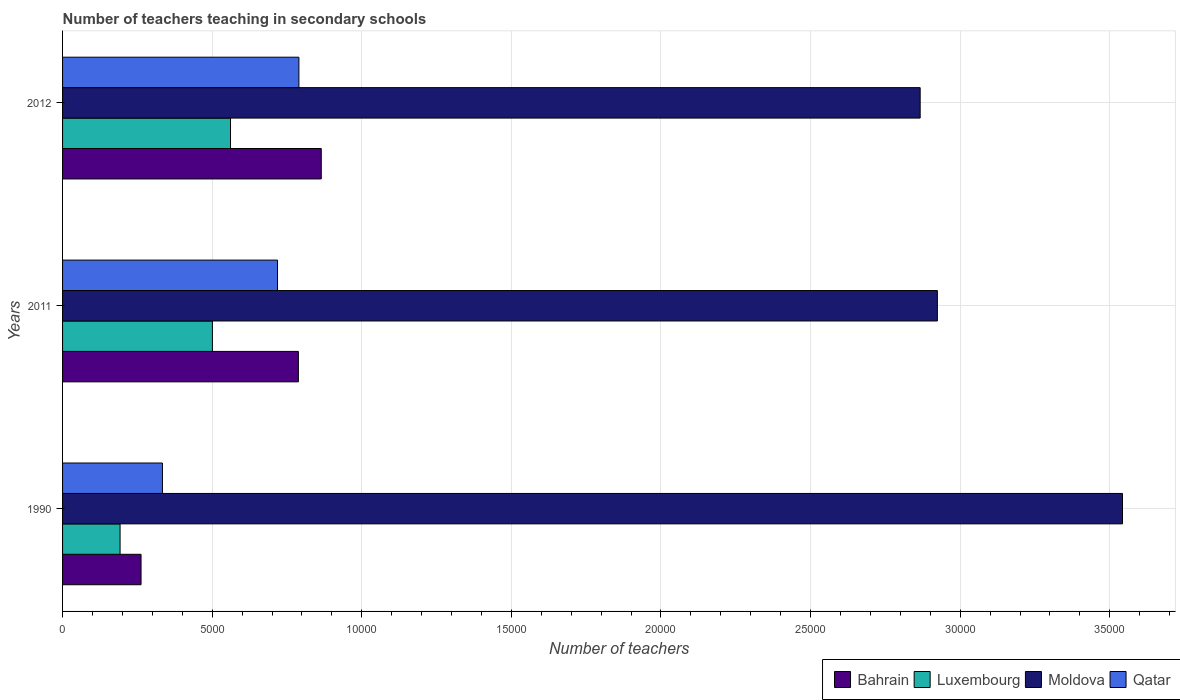What is the label of the 1st group of bars from the top?
Provide a succinct answer. 2012. What is the number of teachers teaching in secondary schools in Moldova in 1990?
Your response must be concise. 3.54e+04. Across all years, what is the maximum number of teachers teaching in secondary schools in Moldova?
Your answer should be very brief. 3.54e+04. Across all years, what is the minimum number of teachers teaching in secondary schools in Luxembourg?
Keep it short and to the point. 1922. In which year was the number of teachers teaching in secondary schools in Moldova maximum?
Give a very brief answer. 1990. In which year was the number of teachers teaching in secondary schools in Luxembourg minimum?
Make the answer very short. 1990. What is the total number of teachers teaching in secondary schools in Moldova in the graph?
Offer a terse response. 9.33e+04. What is the difference between the number of teachers teaching in secondary schools in Bahrain in 2011 and that in 2012?
Offer a terse response. -765. What is the difference between the number of teachers teaching in secondary schools in Bahrain in 1990 and the number of teachers teaching in secondary schools in Moldova in 2011?
Offer a very short reply. -2.66e+04. What is the average number of teachers teaching in secondary schools in Bahrain per year?
Provide a succinct answer. 6383.33. In the year 2012, what is the difference between the number of teachers teaching in secondary schools in Luxembourg and number of teachers teaching in secondary schools in Bahrain?
Give a very brief answer. -3033. What is the ratio of the number of teachers teaching in secondary schools in Bahrain in 1990 to that in 2012?
Offer a terse response. 0.3. Is the number of teachers teaching in secondary schools in Moldova in 1990 less than that in 2011?
Ensure brevity in your answer.  No. Is the difference between the number of teachers teaching in secondary schools in Luxembourg in 2011 and 2012 greater than the difference between the number of teachers teaching in secondary schools in Bahrain in 2011 and 2012?
Ensure brevity in your answer.  Yes. What is the difference between the highest and the second highest number of teachers teaching in secondary schools in Moldova?
Your answer should be compact. 6187. What is the difference between the highest and the lowest number of teachers teaching in secondary schools in Bahrain?
Give a very brief answer. 6023. In how many years, is the number of teachers teaching in secondary schools in Luxembourg greater than the average number of teachers teaching in secondary schools in Luxembourg taken over all years?
Keep it short and to the point. 2. Is the sum of the number of teachers teaching in secondary schools in Qatar in 1990 and 2012 greater than the maximum number of teachers teaching in secondary schools in Bahrain across all years?
Your response must be concise. Yes. Is it the case that in every year, the sum of the number of teachers teaching in secondary schools in Qatar and number of teachers teaching in secondary schools in Bahrain is greater than the sum of number of teachers teaching in secondary schools in Luxembourg and number of teachers teaching in secondary schools in Moldova?
Your answer should be compact. No. What does the 2nd bar from the top in 2011 represents?
Provide a succinct answer. Moldova. What does the 1st bar from the bottom in 2012 represents?
Your response must be concise. Bahrain. Is it the case that in every year, the sum of the number of teachers teaching in secondary schools in Moldova and number of teachers teaching in secondary schools in Luxembourg is greater than the number of teachers teaching in secondary schools in Bahrain?
Ensure brevity in your answer.  Yes. How many bars are there?
Your answer should be very brief. 12. How many years are there in the graph?
Offer a very short reply. 3. What is the difference between two consecutive major ticks on the X-axis?
Ensure brevity in your answer.  5000. Are the values on the major ticks of X-axis written in scientific E-notation?
Provide a short and direct response. No. Does the graph contain any zero values?
Make the answer very short. No. Does the graph contain grids?
Keep it short and to the point. Yes. Where does the legend appear in the graph?
Your response must be concise. Bottom right. How many legend labels are there?
Your answer should be very brief. 4. What is the title of the graph?
Your answer should be compact. Number of teachers teaching in secondary schools. What is the label or title of the X-axis?
Your answer should be compact. Number of teachers. What is the label or title of the Y-axis?
Make the answer very short. Years. What is the Number of teachers in Bahrain in 1990?
Offer a terse response. 2623. What is the Number of teachers in Luxembourg in 1990?
Provide a short and direct response. 1922. What is the Number of teachers in Moldova in 1990?
Give a very brief answer. 3.54e+04. What is the Number of teachers of Qatar in 1990?
Make the answer very short. 3338. What is the Number of teachers in Bahrain in 2011?
Offer a terse response. 7881. What is the Number of teachers of Luxembourg in 2011?
Give a very brief answer. 5008. What is the Number of teachers in Moldova in 2011?
Offer a terse response. 2.92e+04. What is the Number of teachers of Qatar in 2011?
Make the answer very short. 7184. What is the Number of teachers in Bahrain in 2012?
Keep it short and to the point. 8646. What is the Number of teachers of Luxembourg in 2012?
Provide a succinct answer. 5613. What is the Number of teachers in Moldova in 2012?
Keep it short and to the point. 2.87e+04. What is the Number of teachers in Qatar in 2012?
Keep it short and to the point. 7899. Across all years, what is the maximum Number of teachers in Bahrain?
Offer a very short reply. 8646. Across all years, what is the maximum Number of teachers of Luxembourg?
Offer a terse response. 5613. Across all years, what is the maximum Number of teachers in Moldova?
Offer a very short reply. 3.54e+04. Across all years, what is the maximum Number of teachers in Qatar?
Give a very brief answer. 7899. Across all years, what is the minimum Number of teachers in Bahrain?
Keep it short and to the point. 2623. Across all years, what is the minimum Number of teachers in Luxembourg?
Ensure brevity in your answer.  1922. Across all years, what is the minimum Number of teachers in Moldova?
Provide a succinct answer. 2.87e+04. Across all years, what is the minimum Number of teachers of Qatar?
Keep it short and to the point. 3338. What is the total Number of teachers in Bahrain in the graph?
Offer a very short reply. 1.92e+04. What is the total Number of teachers in Luxembourg in the graph?
Your response must be concise. 1.25e+04. What is the total Number of teachers of Moldova in the graph?
Make the answer very short. 9.33e+04. What is the total Number of teachers of Qatar in the graph?
Your response must be concise. 1.84e+04. What is the difference between the Number of teachers of Bahrain in 1990 and that in 2011?
Ensure brevity in your answer.  -5258. What is the difference between the Number of teachers in Luxembourg in 1990 and that in 2011?
Your response must be concise. -3086. What is the difference between the Number of teachers of Moldova in 1990 and that in 2011?
Provide a succinct answer. 6187. What is the difference between the Number of teachers in Qatar in 1990 and that in 2011?
Your answer should be very brief. -3846. What is the difference between the Number of teachers in Bahrain in 1990 and that in 2012?
Give a very brief answer. -6023. What is the difference between the Number of teachers of Luxembourg in 1990 and that in 2012?
Provide a short and direct response. -3691. What is the difference between the Number of teachers in Moldova in 1990 and that in 2012?
Your response must be concise. 6762. What is the difference between the Number of teachers in Qatar in 1990 and that in 2012?
Make the answer very short. -4561. What is the difference between the Number of teachers of Bahrain in 2011 and that in 2012?
Give a very brief answer. -765. What is the difference between the Number of teachers in Luxembourg in 2011 and that in 2012?
Your response must be concise. -605. What is the difference between the Number of teachers of Moldova in 2011 and that in 2012?
Provide a succinct answer. 575. What is the difference between the Number of teachers in Qatar in 2011 and that in 2012?
Your answer should be very brief. -715. What is the difference between the Number of teachers of Bahrain in 1990 and the Number of teachers of Luxembourg in 2011?
Ensure brevity in your answer.  -2385. What is the difference between the Number of teachers of Bahrain in 1990 and the Number of teachers of Moldova in 2011?
Ensure brevity in your answer.  -2.66e+04. What is the difference between the Number of teachers in Bahrain in 1990 and the Number of teachers in Qatar in 2011?
Offer a very short reply. -4561. What is the difference between the Number of teachers in Luxembourg in 1990 and the Number of teachers in Moldova in 2011?
Make the answer very short. -2.73e+04. What is the difference between the Number of teachers of Luxembourg in 1990 and the Number of teachers of Qatar in 2011?
Offer a terse response. -5262. What is the difference between the Number of teachers of Moldova in 1990 and the Number of teachers of Qatar in 2011?
Give a very brief answer. 2.82e+04. What is the difference between the Number of teachers of Bahrain in 1990 and the Number of teachers of Luxembourg in 2012?
Make the answer very short. -2990. What is the difference between the Number of teachers of Bahrain in 1990 and the Number of teachers of Moldova in 2012?
Keep it short and to the point. -2.60e+04. What is the difference between the Number of teachers in Bahrain in 1990 and the Number of teachers in Qatar in 2012?
Your answer should be very brief. -5276. What is the difference between the Number of teachers in Luxembourg in 1990 and the Number of teachers in Moldova in 2012?
Offer a very short reply. -2.67e+04. What is the difference between the Number of teachers in Luxembourg in 1990 and the Number of teachers in Qatar in 2012?
Your response must be concise. -5977. What is the difference between the Number of teachers in Moldova in 1990 and the Number of teachers in Qatar in 2012?
Your answer should be compact. 2.75e+04. What is the difference between the Number of teachers of Bahrain in 2011 and the Number of teachers of Luxembourg in 2012?
Give a very brief answer. 2268. What is the difference between the Number of teachers of Bahrain in 2011 and the Number of teachers of Moldova in 2012?
Ensure brevity in your answer.  -2.08e+04. What is the difference between the Number of teachers of Bahrain in 2011 and the Number of teachers of Qatar in 2012?
Provide a succinct answer. -18. What is the difference between the Number of teachers in Luxembourg in 2011 and the Number of teachers in Moldova in 2012?
Ensure brevity in your answer.  -2.37e+04. What is the difference between the Number of teachers in Luxembourg in 2011 and the Number of teachers in Qatar in 2012?
Offer a terse response. -2891. What is the difference between the Number of teachers of Moldova in 2011 and the Number of teachers of Qatar in 2012?
Keep it short and to the point. 2.13e+04. What is the average Number of teachers of Bahrain per year?
Provide a succinct answer. 6383.33. What is the average Number of teachers of Luxembourg per year?
Your response must be concise. 4181. What is the average Number of teachers of Moldova per year?
Your answer should be very brief. 3.11e+04. What is the average Number of teachers of Qatar per year?
Keep it short and to the point. 6140.33. In the year 1990, what is the difference between the Number of teachers of Bahrain and Number of teachers of Luxembourg?
Your response must be concise. 701. In the year 1990, what is the difference between the Number of teachers of Bahrain and Number of teachers of Moldova?
Offer a terse response. -3.28e+04. In the year 1990, what is the difference between the Number of teachers in Bahrain and Number of teachers in Qatar?
Offer a terse response. -715. In the year 1990, what is the difference between the Number of teachers in Luxembourg and Number of teachers in Moldova?
Offer a very short reply. -3.35e+04. In the year 1990, what is the difference between the Number of teachers of Luxembourg and Number of teachers of Qatar?
Offer a very short reply. -1416. In the year 1990, what is the difference between the Number of teachers in Moldova and Number of teachers in Qatar?
Offer a very short reply. 3.21e+04. In the year 2011, what is the difference between the Number of teachers in Bahrain and Number of teachers in Luxembourg?
Your response must be concise. 2873. In the year 2011, what is the difference between the Number of teachers in Bahrain and Number of teachers in Moldova?
Make the answer very short. -2.14e+04. In the year 2011, what is the difference between the Number of teachers of Bahrain and Number of teachers of Qatar?
Provide a succinct answer. 697. In the year 2011, what is the difference between the Number of teachers in Luxembourg and Number of teachers in Moldova?
Keep it short and to the point. -2.42e+04. In the year 2011, what is the difference between the Number of teachers in Luxembourg and Number of teachers in Qatar?
Make the answer very short. -2176. In the year 2011, what is the difference between the Number of teachers of Moldova and Number of teachers of Qatar?
Give a very brief answer. 2.21e+04. In the year 2012, what is the difference between the Number of teachers in Bahrain and Number of teachers in Luxembourg?
Ensure brevity in your answer.  3033. In the year 2012, what is the difference between the Number of teachers of Bahrain and Number of teachers of Moldova?
Offer a very short reply. -2.00e+04. In the year 2012, what is the difference between the Number of teachers of Bahrain and Number of teachers of Qatar?
Give a very brief answer. 747. In the year 2012, what is the difference between the Number of teachers in Luxembourg and Number of teachers in Moldova?
Offer a very short reply. -2.30e+04. In the year 2012, what is the difference between the Number of teachers of Luxembourg and Number of teachers of Qatar?
Make the answer very short. -2286. In the year 2012, what is the difference between the Number of teachers in Moldova and Number of teachers in Qatar?
Your answer should be compact. 2.08e+04. What is the ratio of the Number of teachers of Bahrain in 1990 to that in 2011?
Your answer should be very brief. 0.33. What is the ratio of the Number of teachers of Luxembourg in 1990 to that in 2011?
Give a very brief answer. 0.38. What is the ratio of the Number of teachers of Moldova in 1990 to that in 2011?
Make the answer very short. 1.21. What is the ratio of the Number of teachers in Qatar in 1990 to that in 2011?
Offer a terse response. 0.46. What is the ratio of the Number of teachers of Bahrain in 1990 to that in 2012?
Make the answer very short. 0.3. What is the ratio of the Number of teachers in Luxembourg in 1990 to that in 2012?
Offer a very short reply. 0.34. What is the ratio of the Number of teachers of Moldova in 1990 to that in 2012?
Your response must be concise. 1.24. What is the ratio of the Number of teachers of Qatar in 1990 to that in 2012?
Give a very brief answer. 0.42. What is the ratio of the Number of teachers of Bahrain in 2011 to that in 2012?
Your response must be concise. 0.91. What is the ratio of the Number of teachers in Luxembourg in 2011 to that in 2012?
Your answer should be very brief. 0.89. What is the ratio of the Number of teachers of Moldova in 2011 to that in 2012?
Keep it short and to the point. 1.02. What is the ratio of the Number of teachers in Qatar in 2011 to that in 2012?
Offer a terse response. 0.91. What is the difference between the highest and the second highest Number of teachers of Bahrain?
Provide a succinct answer. 765. What is the difference between the highest and the second highest Number of teachers in Luxembourg?
Offer a terse response. 605. What is the difference between the highest and the second highest Number of teachers of Moldova?
Ensure brevity in your answer.  6187. What is the difference between the highest and the second highest Number of teachers in Qatar?
Your answer should be very brief. 715. What is the difference between the highest and the lowest Number of teachers in Bahrain?
Your answer should be compact. 6023. What is the difference between the highest and the lowest Number of teachers of Luxembourg?
Give a very brief answer. 3691. What is the difference between the highest and the lowest Number of teachers of Moldova?
Give a very brief answer. 6762. What is the difference between the highest and the lowest Number of teachers of Qatar?
Provide a succinct answer. 4561. 